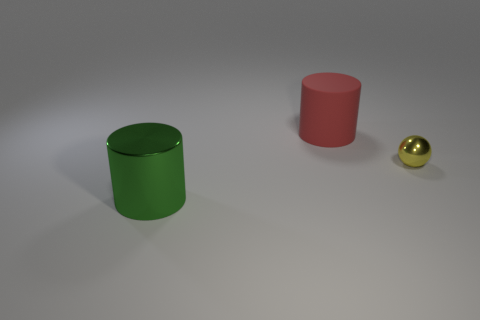Are there any other things that are the same size as the yellow shiny thing?
Make the answer very short. No. Is there any other thing that is the same material as the large red object?
Your response must be concise. No. How many small things are red metal spheres or cylinders?
Your answer should be compact. 0. How many other things are the same size as the green thing?
Provide a short and direct response. 1. There is a large thing in front of the red cylinder; is its shape the same as the large matte thing?
Give a very brief answer. Yes. What is the color of the other big object that is the same shape as the rubber thing?
Offer a terse response. Green. Are there any other things that are the same shape as the tiny yellow shiny object?
Provide a succinct answer. No. Are there the same number of metallic cylinders right of the small yellow sphere and small metallic things?
Make the answer very short. No. How many objects are behind the big green cylinder and in front of the red thing?
Give a very brief answer. 1. What number of large green cylinders have the same material as the tiny yellow ball?
Make the answer very short. 1. 